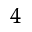<formula> <loc_0><loc_0><loc_500><loc_500>^ { 4 }</formula> 